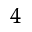<formula> <loc_0><loc_0><loc_500><loc_500>^ { 4 }</formula> 